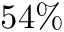<formula> <loc_0><loc_0><loc_500><loc_500>5 4 \%</formula> 